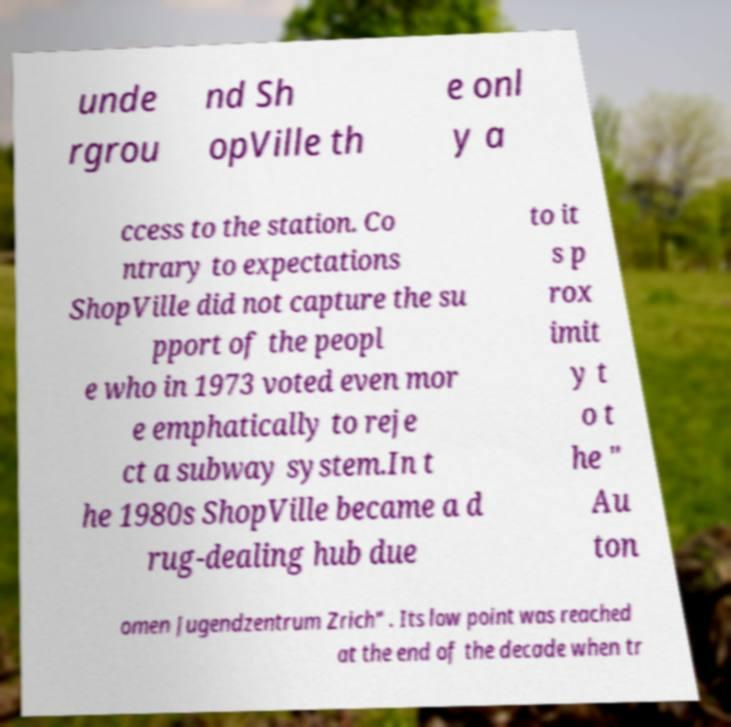Can you accurately transcribe the text from the provided image for me? unde rgrou nd Sh opVille th e onl y a ccess to the station. Co ntrary to expectations ShopVille did not capture the su pport of the peopl e who in 1973 voted even mor e emphatically to reje ct a subway system.In t he 1980s ShopVille became a d rug-dealing hub due to it s p rox imit y t o t he " Au ton omen Jugendzentrum Zrich" . Its low point was reached at the end of the decade when tr 